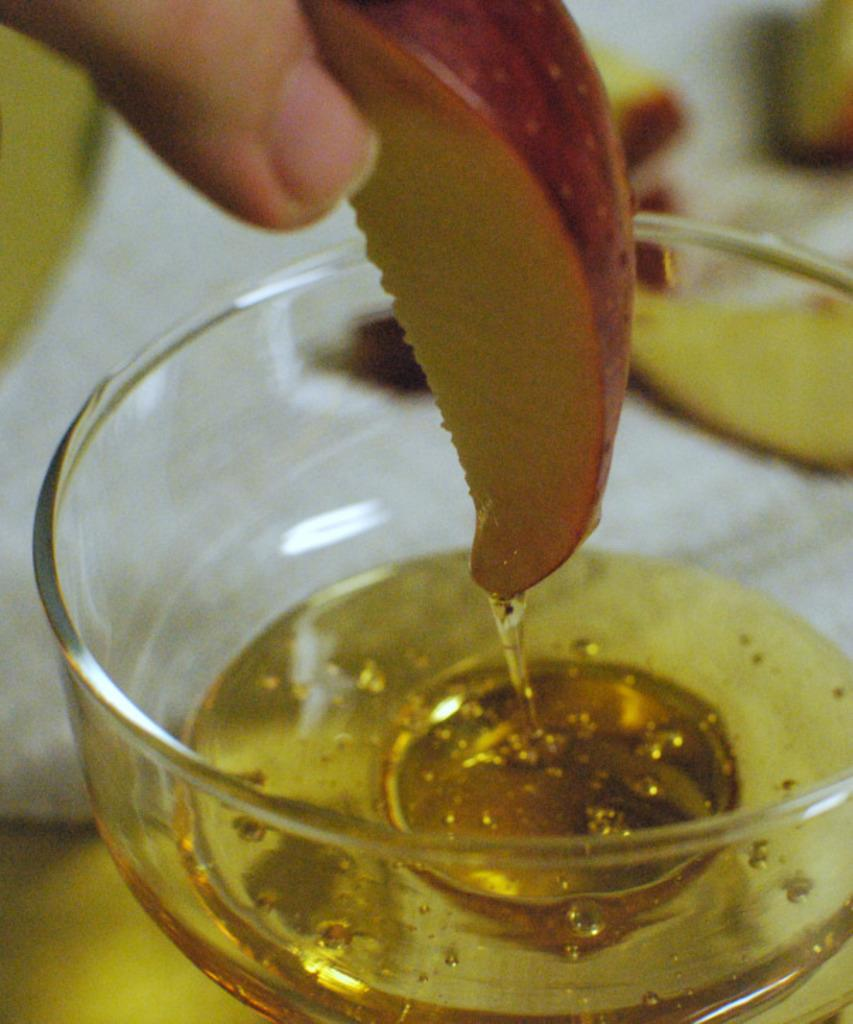What object in the image contains a liquid? There is a glass bowl in the image that contains a liquid. What is the person's hand doing in the image? The person's hand is holding a slice of apple. How is the apple slice being used in the image? The apple slice is dipped into the liquid in the glass bowl. What type of bells can be heard ringing in the image? There are no bells present in the image, and therefore no sound can be heard. 